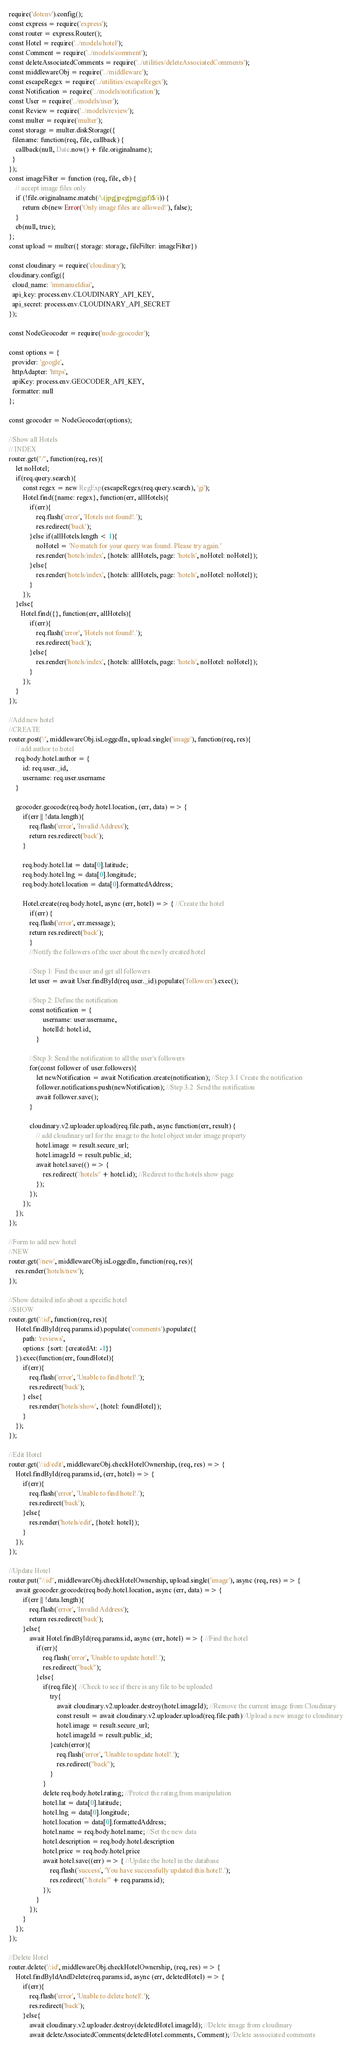Convert code to text. <code><loc_0><loc_0><loc_500><loc_500><_JavaScript_>require('dotenv').config();
const express = require('express');
const router = express.Router();
const Hotel = require('../models/hotel');
const Comment = require('../models/comment');
const deleteAssociatedComments = require('../utilities/deleteAssociatedComments');
const middlewareObj = require('../middleware');
const escapeRegex = require('../utilities/escapeRegex');
const Notification = require('../models/notification');
const User = require('../models/user');
const Review = require('../models/review');
const multer = require('multer');
const storage = multer.diskStorage({
  filename: function(req, file, callback) {
    callback(null, Date.now() + file.originalname);
  }
});
const imageFilter = function (req, file, cb) {
    // accept image files only
    if (!file.originalname.match(/\.(jpg|jpeg|png|gif)$/i)) {
        return cb(new Error('Only image files are allowed!'), false);
    }
    cb(null, true);
};
const upload = multer({ storage: storage, fileFilter: imageFilter})

const cloudinary = require('cloudinary');
cloudinary.config({ 
  cloud_name: 'immanueldiai', 
  api_key: process.env.CLOUDINARY_API_KEY, 
  api_secret: process.env.CLOUDINARY_API_SECRET
});

const NodeGeocoder = require('node-geocoder');
 
const options = {
  provider: 'google',
  httpAdapter: 'https',
  apiKey: process.env.GEOCODER_API_KEY,
  formatter: null
};
 
const geocoder = NodeGeocoder(options);

//Show all Hotels
// INDEX
router.get("/", function(req, res){
    let noHotel;
    if(req.query.search){
        const regex = new RegExp(escapeRegex(req.query.search), 'gi');
        Hotel.find({name: regex}, function(err, allHotels){
            if(err){
                req.flash('error', 'Hotels not found!.');
                res.redirect('back');
            }else if(allHotels.length < 1){
                noHotel = 'No match for your query was found. Please try again.'
                res.render('hotels/index', {hotels: allHotels, page: 'hotels', noHotel: noHotel});        
            }else{
                res.render('hotels/index', {hotels: allHotels, page: 'hotels', noHotel: noHotel});        
            }
        });
    }else{
       Hotel.find({}, function(err, allHotels){
            if(err){
                req.flash('error', 'Hotels not found!.');
                res.redirect('back');
            }else{
                res.render('hotels/index', {hotels: allHotels, page: 'hotels', noHotel: noHotel});        
            }
        }); 
    }
});

//Add new hotel
//CREATE
router.post('/', middlewareObj.isLoggedIn, upload.single('image'), function(req, res){
    // add author to hotel
    req.body.hotel.author = {
        id: req.user._id,
        username: req.user.username
    }

    geocoder.geocode(req.body.hotel.location, (err, data) => {
        if(err || !data.length){
            req.flash('error', 'Invalid Address');
            return res.redirect('back');
        }

        req.body.hotel.lat = data[0].latitude;
        req.body.hotel.lng = data[0].longitude;
        req.body.hotel.location = data[0].formattedAddress;

        Hotel.create(req.body.hotel, async (err, hotel) => { //Create the hotel
            if(err) {
            req.flash('error', err.message);
            return res.redirect('back');
            }
            //Notify the followers of the user about the newly created hotel
            
            //Step 1: Find the user and get all followers
            let user = await User.findById(req.user._id).populate('followers').exec();
            
            //Step 2: Define the notification
            const notification = {
                    username: user.username,
                    hotelId: hotel.id,
                }
    
            //Step 3: Send the notification to all the user's followers
            for(const follower of user.followers){
                let newNotification = await Notification.create(notification); //Step 3.1 Create the notification
                follower.notifications.push(newNotification); //Step 3.2  Send the notification
                await follower.save();
            }
    
            cloudinary.v2.uploader.upload(req.file.path, async function(err, result) {
                // add cloudinary url for the image to the hotel object under image property
                hotel.image = result.secure_url;
                hotel.imageId = result.public_id;
                await hotel.save(() => {
                    res.redirect('/hotels/' + hotel.id); //Redirect to the hotels show page
                });
            }); 
        });
    });
});

//Form to add new hotel
//NEW
router.get('/new', middlewareObj.isLoggedIn, function(req, res){
    res.render('hotels/new');
});

//Show detailed info about a specific hotel
//SHOW
router.get('/:id', function(req, res){
    Hotel.findById(req.params.id).populate('comments').populate({
        path: 'reviews',
        options: {sort: {createdAt: -1}}
    }).exec(function(err, foundHotel){
        if(err){
            req.flash('error', 'Unable to find hotel!.');
            res.redirect('back');
        } else{
            res.render('hotels/show', {hotel: foundHotel});
        }
    });
});

//Edit Hotel
router.get('/:id/edit', middlewareObj.checkHotelOwnership, (req, res) => { 
    Hotel.findById(req.params.id, (err, hotel) => {
        if(err){
            req.flash('error', 'Unable to find hotel!.');
            res.redirect('back');
        }else{
            res.render('hotels/edit', {hotel: hotel});
        }
    });  
});

//Update Hotel
router.put("/:id", middlewareObj.checkHotelOwnership, upload.single('image'), async (req, res) => {
    await geocoder.geocode(req.body.hotel.location, async (err, data) => {
        if(err || !data.length){
            req.flash('error', 'Invalid Address');
            return res.redirect('back');  
        }else{
            await Hotel.findById(req.params.id, async (err, hotel) => { //Find the hotel
                if(err){
                    req.flash('error', 'Unable to update hotel!.');
                    res.redirect("back");
                }else{
                    if(req.file){ //Check to see if there is any file to be uploaded
                        try{
                            await cloudinary.v2.uploader.destroy(hotel.imageId); //Remove the current image from Cloudinary
                            const result = await cloudinary.v2.uploader.upload(req.file.path)//Upload a new image to cloudinary
                            hotel.image = result.secure_url;
                            hotel.imageId = result.public_id;
                        }catch(error){
                            req.flash('error', 'Unable to update hotel!.');
                            res.redirect("back");
                        }
                    }
                    delete req.body.hotel.rating; //Protect the rating from manipulation
                    hotel.lat = data[0].latitude;
                    hotel.lng = data[0].longitude;
                    hotel.location = data[0].formattedAddress;
                    hotel.name = req.body.hotel.name; //Set the new data
                    hotel.description = req.body.hotel.description
                    hotel.price = req.body.hotel.price
                    await hotel.save((err) => { //Update the hotel in the database
                        req.flash('success', 'You have successfully updated this hotel!.');
                        res.redirect("/hotels/" + req.params.id);
                    });  
                }
            });
        }
    });
});

//Delete Hotel
router.delete('/:id', middlewareObj.checkHotelOwnership, (req, res) => {
    Hotel.findByIdAndDelete(req.params.id, async (err, deletedHotel) => {
        if(err){
            req.flash('error', 'Unable to delete hotel!.');
            res.redirect('back');
        }else{
            await cloudinary.v2.uploader.destroy(deletedHotel.imageId); //Delete image from cloudinary
            await deleteAssociatedComments(deletedHotel.comments, Comment);//Delete asssociated comments</code> 